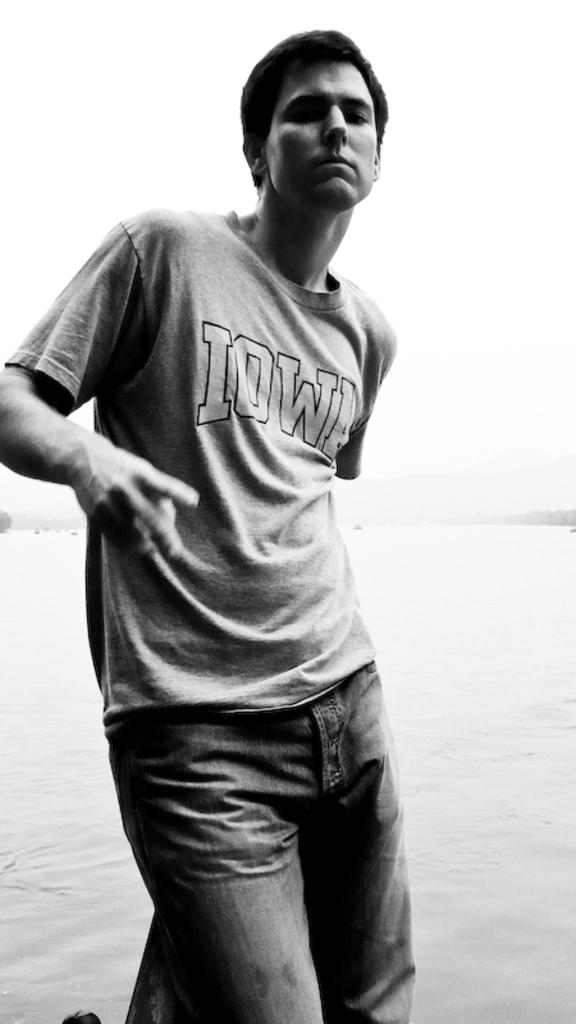What is the main subject of the image? There is a person standing in the image. What can be seen in the background of the image? Water and the sky are visible in the image. Can you tell me how many walls are visible in the image? There are no walls visible in the image; it features a person standing near water and the sky. What type of action is the person performing in the image? The provided facts do not specify any action being performed by the person in the image. 